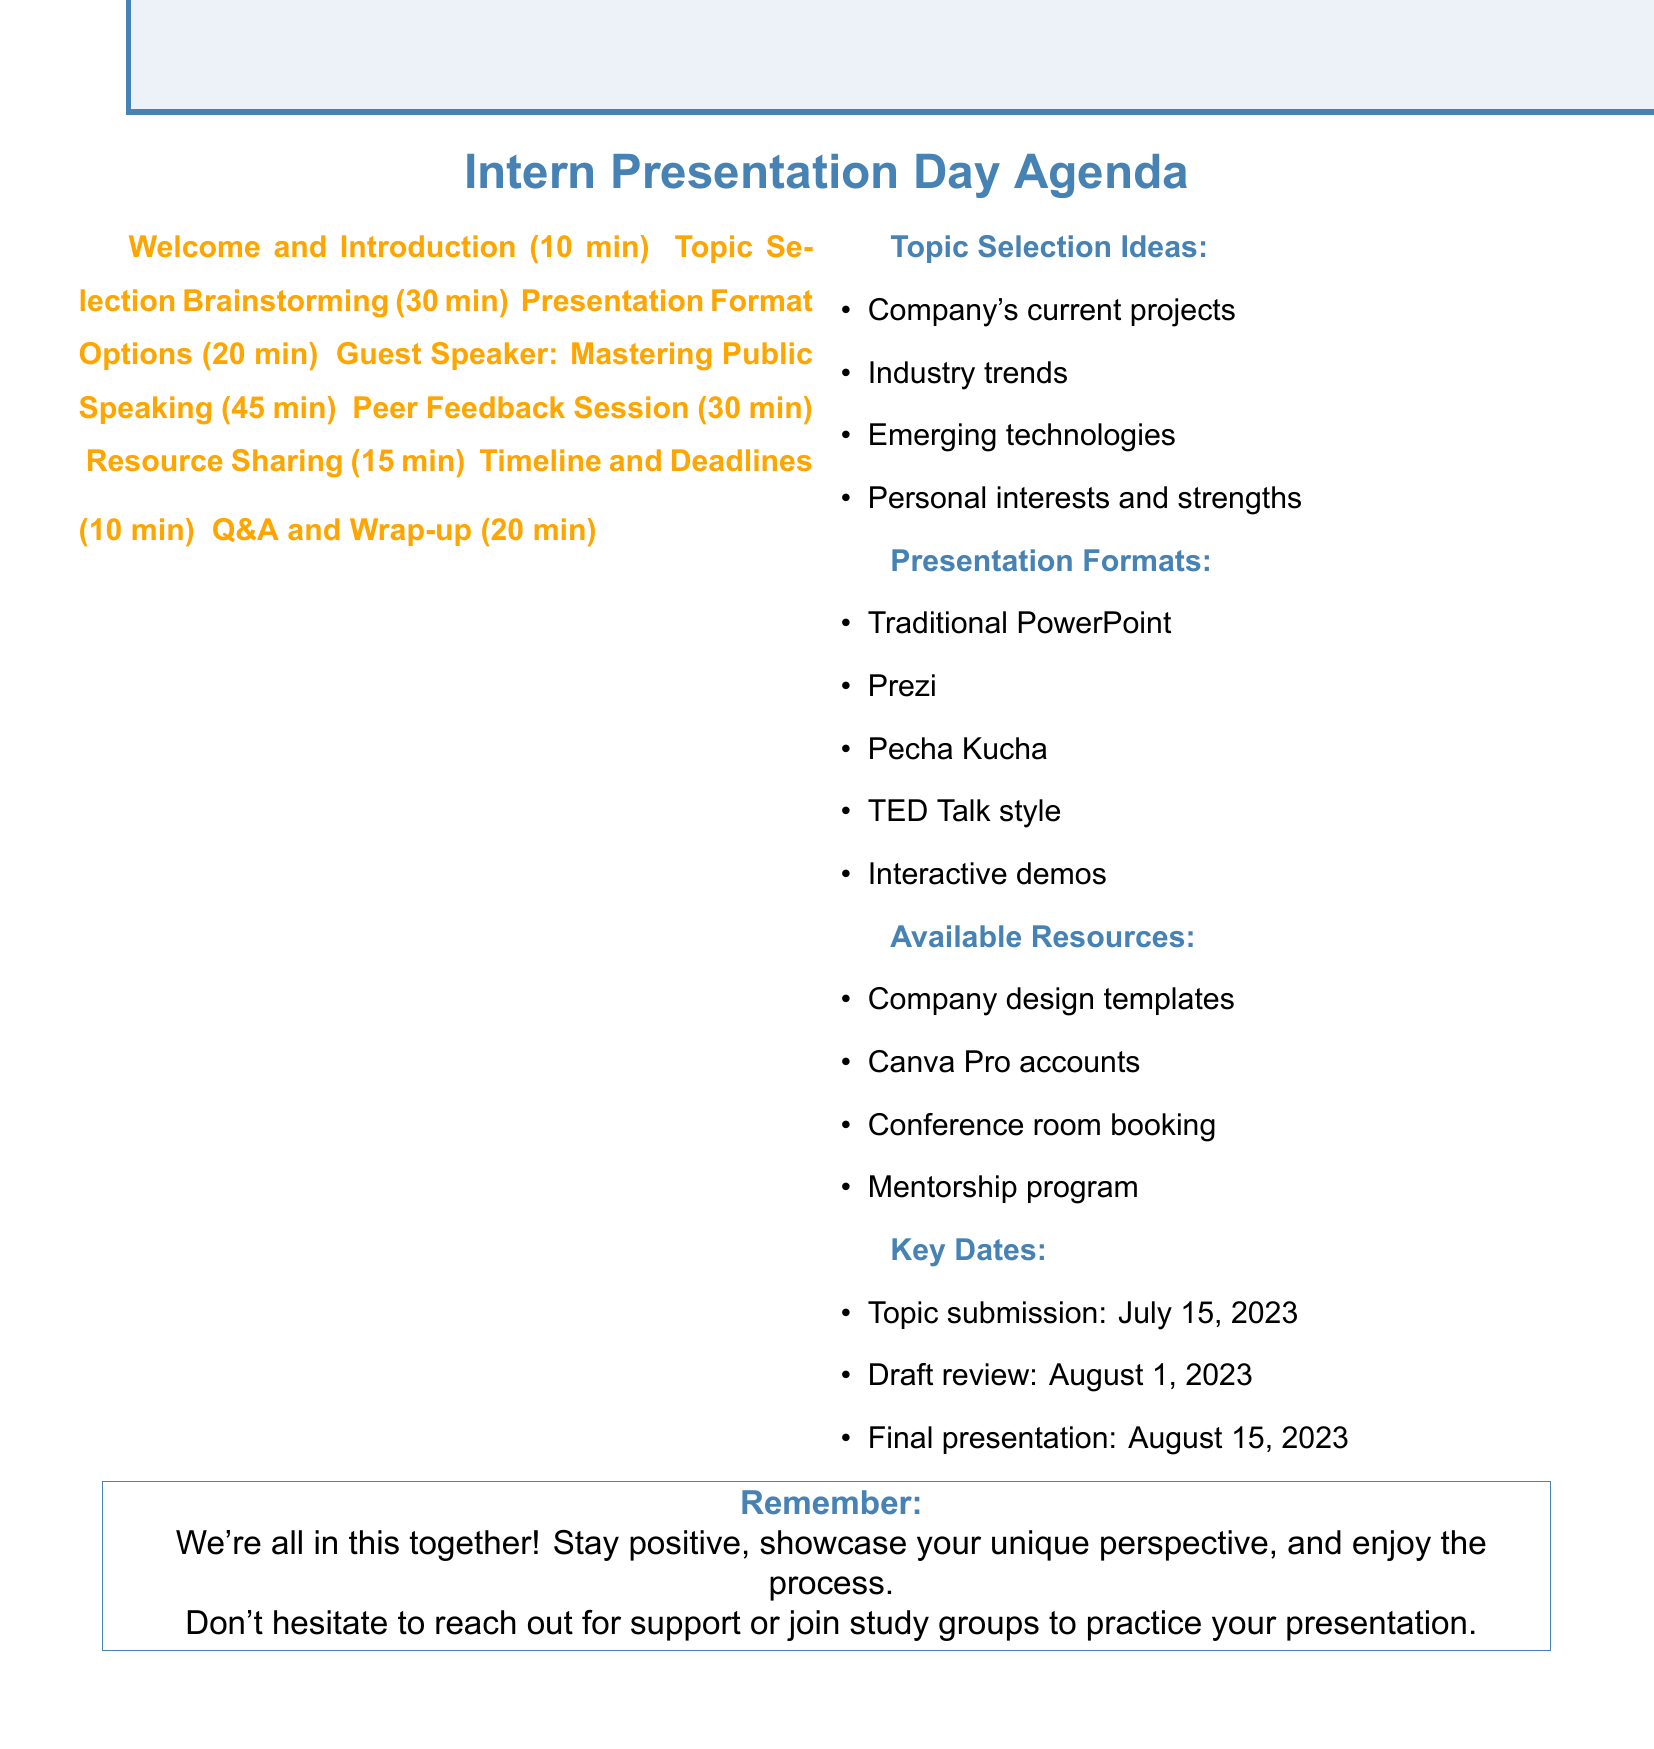what is the duration of the Peer Feedback Session? The Peer Feedback Session is listed under the agenda items with a duration of 30 minutes.
Answer: 30 minutes who is the guest speaker presenting tips on public speaking? The agenda specifies that the guest speaker is Alex Rodriguez, who will provide tips on mastering public speaking.
Answer: Alex Rodriguez what are the available tools for presentation preparation? The agenda includes a section on Resource Sharing, where the tools and support for presentation preparation are listed.
Answer: Company design templates, Canva Pro accounts, Conference room booking, Mentorship program when is the final presentation day? The Timeline and Deadlines section in the agenda outlines important dates, including the final presentation day.
Answer: August 15, 2023 how long is the session on Presentation Format Options? The Presentation Format Options item specifies the duration of the session as 20 minutes in the agenda.
Answer: 20 minutes what type of presentation style is included as an option? In the Presentation Format Options section, various styles are listed, one of which is the "TED Talk style."
Answer: TED Talk style what is one of the suggested preparation activities? The additional notes suggest various preparation activities, one being forming study groups with other interns to practice presentations.
Answer: Form study groups with other interns to practice presentations how many minutes are allocated for the Welcome and Introduction? The Welcome and Introduction section of the agenda indicates that 10 minutes are allocated for this item.
Answer: 10 minutes 